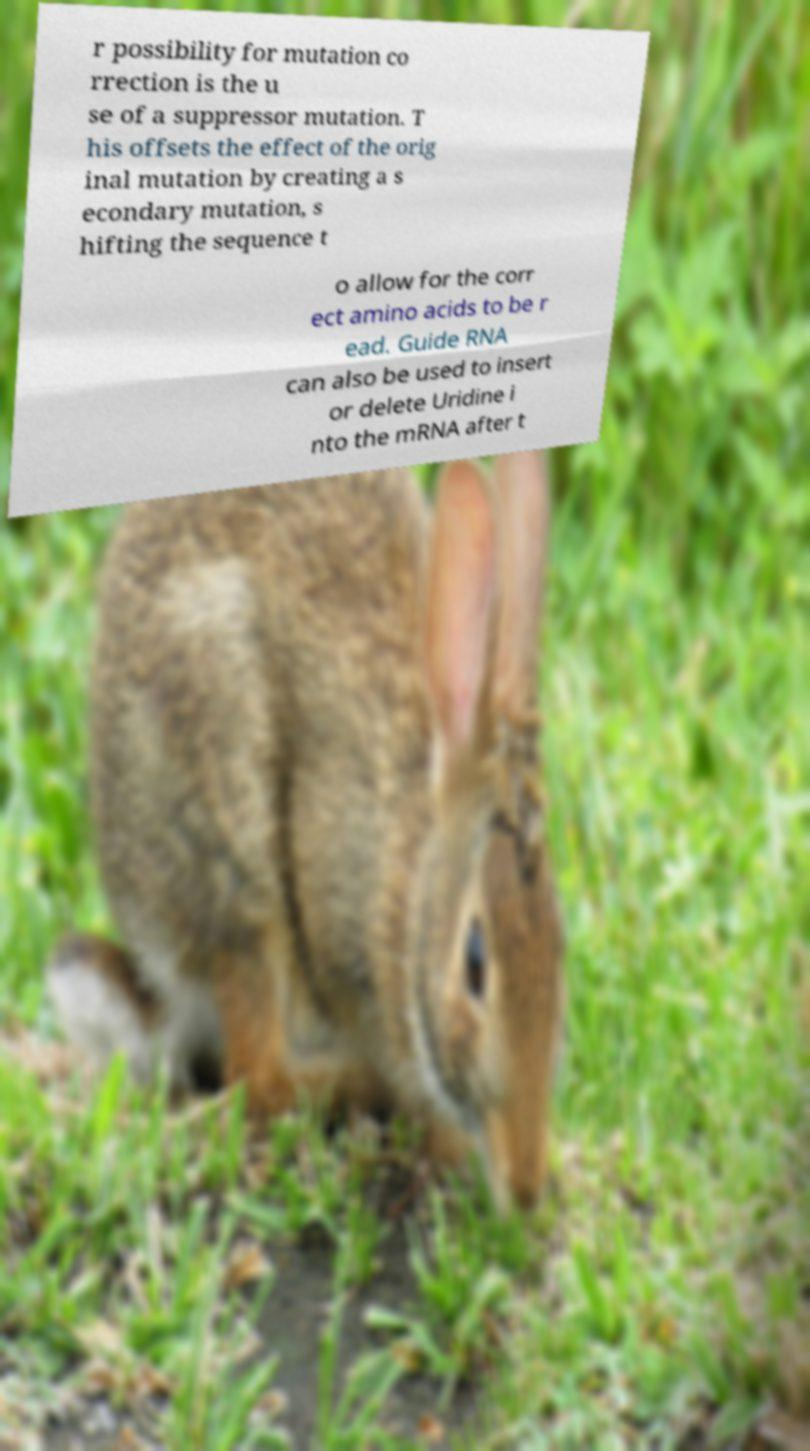What messages or text are displayed in this image? I need them in a readable, typed format. r possibility for mutation co rrection is the u se of a suppressor mutation. T his offsets the effect of the orig inal mutation by creating a s econdary mutation, s hifting the sequence t o allow for the corr ect amino acids to be r ead. Guide RNA can also be used to insert or delete Uridine i nto the mRNA after t 